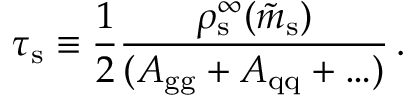<formula> <loc_0><loc_0><loc_500><loc_500>\tau _ { s } \equiv \frac { 1 } { 2 } { \frac { \rho _ { s } ^ { \infty } ( \tilde { m } _ { s } ) } { ( A _ { g g } + A _ { q q } + \dots ) } } \, .</formula> 